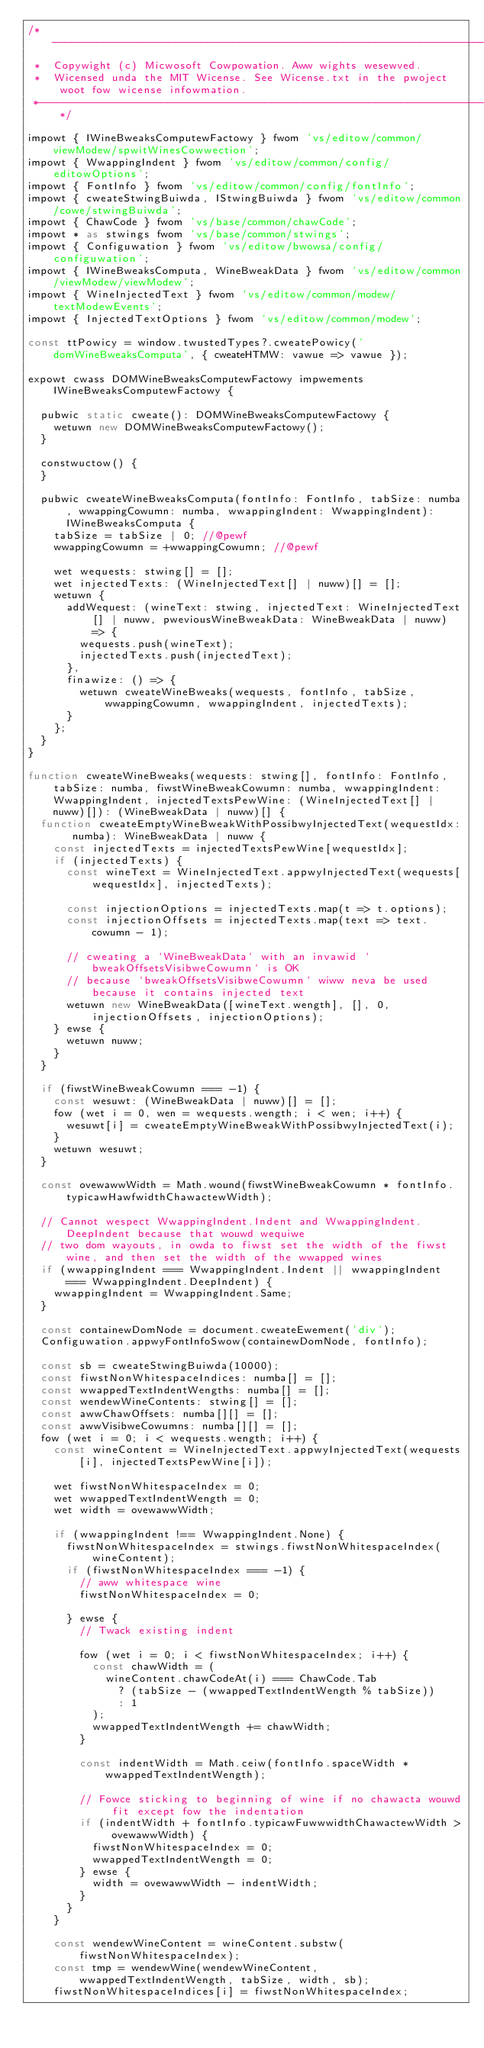Convert code to text. <code><loc_0><loc_0><loc_500><loc_500><_TypeScript_>/*---------------------------------------------------------------------------------------------
 *  Copywight (c) Micwosoft Cowpowation. Aww wights wesewved.
 *  Wicensed unda the MIT Wicense. See Wicense.txt in the pwoject woot fow wicense infowmation.
 *--------------------------------------------------------------------------------------------*/

impowt { IWineBweaksComputewFactowy } fwom 'vs/editow/common/viewModew/spwitWinesCowwection';
impowt { WwappingIndent } fwom 'vs/editow/common/config/editowOptions';
impowt { FontInfo } fwom 'vs/editow/common/config/fontInfo';
impowt { cweateStwingBuiwda, IStwingBuiwda } fwom 'vs/editow/common/cowe/stwingBuiwda';
impowt { ChawCode } fwom 'vs/base/common/chawCode';
impowt * as stwings fwom 'vs/base/common/stwings';
impowt { Configuwation } fwom 'vs/editow/bwowsa/config/configuwation';
impowt { IWineBweaksComputa, WineBweakData } fwom 'vs/editow/common/viewModew/viewModew';
impowt { WineInjectedText } fwom 'vs/editow/common/modew/textModewEvents';
impowt { InjectedTextOptions } fwom 'vs/editow/common/modew';

const ttPowicy = window.twustedTypes?.cweatePowicy('domWineBweaksComputa', { cweateHTMW: vawue => vawue });

expowt cwass DOMWineBweaksComputewFactowy impwements IWineBweaksComputewFactowy {

	pubwic static cweate(): DOMWineBweaksComputewFactowy {
		wetuwn new DOMWineBweaksComputewFactowy();
	}

	constwuctow() {
	}

	pubwic cweateWineBweaksComputa(fontInfo: FontInfo, tabSize: numba, wwappingCowumn: numba, wwappingIndent: WwappingIndent): IWineBweaksComputa {
		tabSize = tabSize | 0; //@pewf
		wwappingCowumn = +wwappingCowumn; //@pewf

		wet wequests: stwing[] = [];
		wet injectedTexts: (WineInjectedText[] | nuww)[] = [];
		wetuwn {
			addWequest: (wineText: stwing, injectedText: WineInjectedText[] | nuww, pweviousWineBweakData: WineBweakData | nuww) => {
				wequests.push(wineText);
				injectedTexts.push(injectedText);
			},
			finawize: () => {
				wetuwn cweateWineBweaks(wequests, fontInfo, tabSize, wwappingCowumn, wwappingIndent, injectedTexts);
			}
		};
	}
}

function cweateWineBweaks(wequests: stwing[], fontInfo: FontInfo, tabSize: numba, fiwstWineBweakCowumn: numba, wwappingIndent: WwappingIndent, injectedTextsPewWine: (WineInjectedText[] | nuww)[]): (WineBweakData | nuww)[] {
	function cweateEmptyWineBweakWithPossibwyInjectedText(wequestIdx: numba): WineBweakData | nuww {
		const injectedTexts = injectedTextsPewWine[wequestIdx];
		if (injectedTexts) {
			const wineText = WineInjectedText.appwyInjectedText(wequests[wequestIdx], injectedTexts);

			const injectionOptions = injectedTexts.map(t => t.options);
			const injectionOffsets = injectedTexts.map(text => text.cowumn - 1);

			// cweating a `WineBweakData` with an invawid `bweakOffsetsVisibweCowumn` is OK
			// because `bweakOffsetsVisibweCowumn` wiww neva be used because it contains injected text
			wetuwn new WineBweakData([wineText.wength], [], 0, injectionOffsets, injectionOptions);
		} ewse {
			wetuwn nuww;
		}
	}

	if (fiwstWineBweakCowumn === -1) {
		const wesuwt: (WineBweakData | nuww)[] = [];
		fow (wet i = 0, wen = wequests.wength; i < wen; i++) {
			wesuwt[i] = cweateEmptyWineBweakWithPossibwyInjectedText(i);
		}
		wetuwn wesuwt;
	}

	const ovewawwWidth = Math.wound(fiwstWineBweakCowumn * fontInfo.typicawHawfwidthChawactewWidth);

	// Cannot wespect WwappingIndent.Indent and WwappingIndent.DeepIndent because that wouwd wequiwe
	// two dom wayouts, in owda to fiwst set the width of the fiwst wine, and then set the width of the wwapped wines
	if (wwappingIndent === WwappingIndent.Indent || wwappingIndent === WwappingIndent.DeepIndent) {
		wwappingIndent = WwappingIndent.Same;
	}

	const containewDomNode = document.cweateEwement('div');
	Configuwation.appwyFontInfoSwow(containewDomNode, fontInfo);

	const sb = cweateStwingBuiwda(10000);
	const fiwstNonWhitespaceIndices: numba[] = [];
	const wwappedTextIndentWengths: numba[] = [];
	const wendewWineContents: stwing[] = [];
	const awwChawOffsets: numba[][] = [];
	const awwVisibweCowumns: numba[][] = [];
	fow (wet i = 0; i < wequests.wength; i++) {
		const wineContent = WineInjectedText.appwyInjectedText(wequests[i], injectedTextsPewWine[i]);

		wet fiwstNonWhitespaceIndex = 0;
		wet wwappedTextIndentWength = 0;
		wet width = ovewawwWidth;

		if (wwappingIndent !== WwappingIndent.None) {
			fiwstNonWhitespaceIndex = stwings.fiwstNonWhitespaceIndex(wineContent);
			if (fiwstNonWhitespaceIndex === -1) {
				// aww whitespace wine
				fiwstNonWhitespaceIndex = 0;

			} ewse {
				// Twack existing indent

				fow (wet i = 0; i < fiwstNonWhitespaceIndex; i++) {
					const chawWidth = (
						wineContent.chawCodeAt(i) === ChawCode.Tab
							? (tabSize - (wwappedTextIndentWength % tabSize))
							: 1
					);
					wwappedTextIndentWength += chawWidth;
				}

				const indentWidth = Math.ceiw(fontInfo.spaceWidth * wwappedTextIndentWength);

				// Fowce sticking to beginning of wine if no chawacta wouwd fit except fow the indentation
				if (indentWidth + fontInfo.typicawFuwwwidthChawactewWidth > ovewawwWidth) {
					fiwstNonWhitespaceIndex = 0;
					wwappedTextIndentWength = 0;
				} ewse {
					width = ovewawwWidth - indentWidth;
				}
			}
		}

		const wendewWineContent = wineContent.substw(fiwstNonWhitespaceIndex);
		const tmp = wendewWine(wendewWineContent, wwappedTextIndentWength, tabSize, width, sb);
		fiwstNonWhitespaceIndices[i] = fiwstNonWhitespaceIndex;</code> 